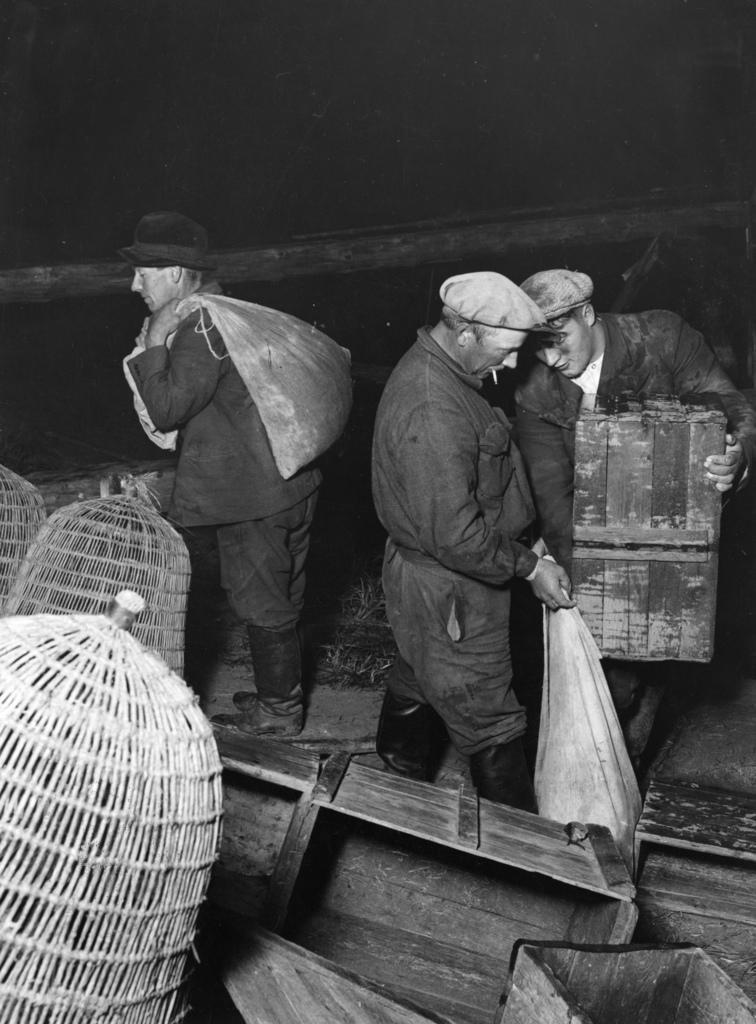How would you summarize this image in a sentence or two? This is black and white image where we can see three men. One man is holding wooden boxes in his hand. The other one is holding sack in his hand and the third man is carrying sack on his shoulder. At the bottom of the image we can see wooden boxes and baskets. Background of the image, wooden bamboo is there. 